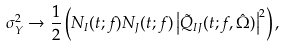<formula> <loc_0><loc_0><loc_500><loc_500>\sigma _ { Y } ^ { 2 } \rightarrow \frac { 1 } { 2 } \left ( N _ { I } ( t ; f ) N _ { J } ( t ; f ) \left | \tilde { Q } _ { I J } ( t ; f , \hat { \Omega } ) \right | ^ { 2 } \right ) ,</formula> 